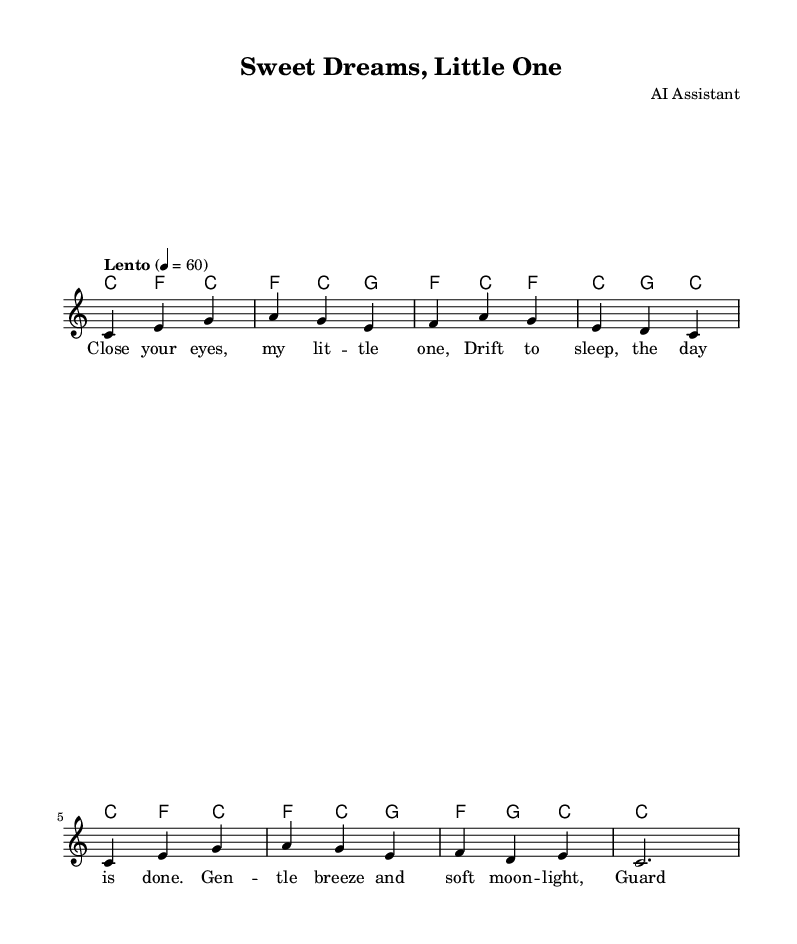What is the key signature of this music? The key signature is C major, which has no sharps or flats.
Answer: C major What is the time signature of this piece? The time signature is indicated at the beginning of the score and is shown as 3/4, meaning there are three beats per measure.
Answer: 3/4 What is the tempo marking for this lullaby? The tempo marking is found at the start of the piece, noted as "Lento," which indicates a slow speed of performance.
Answer: Lento How many measures are there in the melody? By counting the sections separated by the vertical lines in the score, we find that there are eight measures in the melody.
Answer: Eight What is the first note of the melody? The first note of the melody is found in the first measure and is identified as 'C' in the treble clef, which is situated on the first line of the staff.
Answer: C Which word corresponds to the first note in the lyrics? The first note 'C' corresponds to the word "Close," as seen in the lyrics aligned under the melody notes.
Answer: Close 